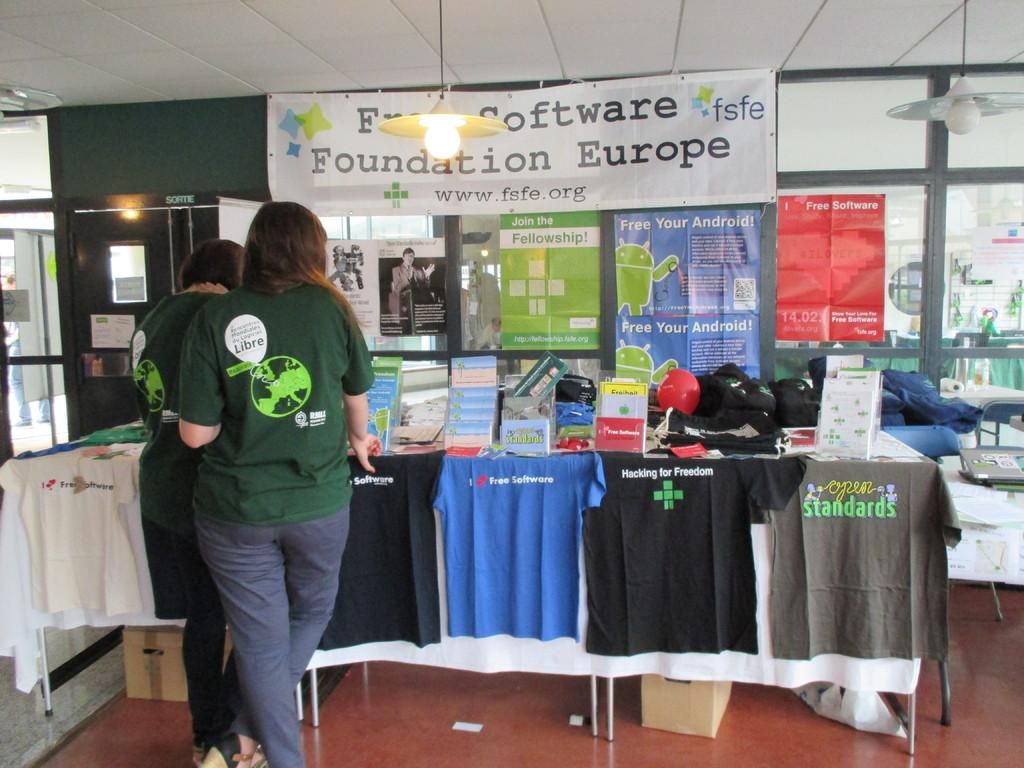<image>
Describe the image concisely. a software foundation europe sign that is in a store 